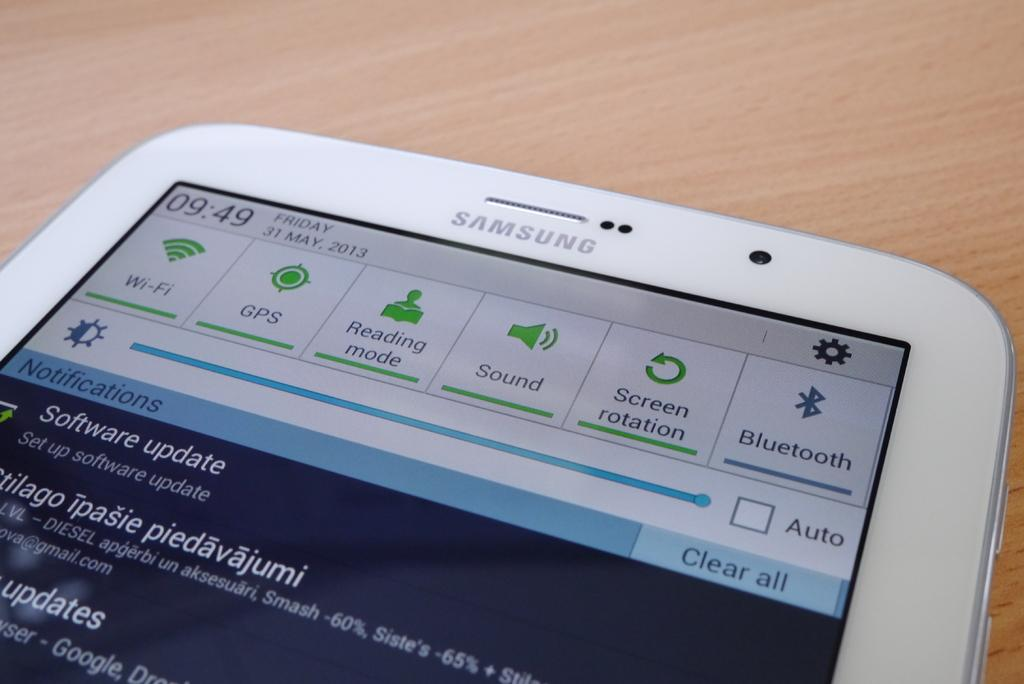<image>
Summarize the visual content of the image. A white phone with a settings screen showing is a Samsung brand phone. 